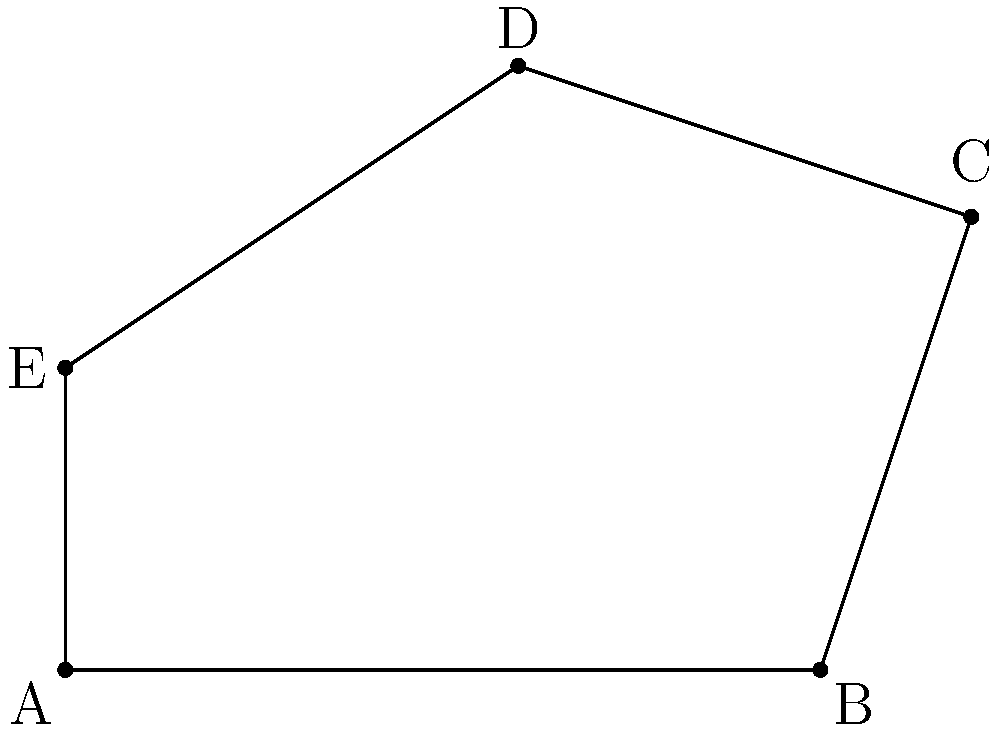As a health inspector, you're assessing a restaurant's food preparation area. The owner has designed an irregular-shaped countertop to maximize space efficiency. The coordinates (in feet) of the countertop's corners are A(0,0), B(5,0), C(6,3), D(3,4), and E(0,2). Calculate the total surface area of this food preparation surface to ensure it meets the minimum size requirements for safe food handling. To calculate the area of this irregular polygon, we can use the Shoelace formula (also known as the surveyor's formula). The steps are as follows:

1) First, let's arrange the coordinates in order:
   (0,0), (5,0), (6,3), (3,4), (0,2)

2) Apply the Shoelace formula:
   Area = $\frac{1}{2}|((x_1y_2 + x_2y_3 + x_3y_4 + x_4y_5 + x_5y_1) - (y_1x_2 + y_2x_3 + y_3x_4 + y_4x_5 + y_5x_1))|$

3) Substituting the values:
   Area = $\frac{1}{2}|((0 \cdot 0 + 5 \cdot 3 + 6 \cdot 4 + 3 \cdot 2 + 0 \cdot 0) - (0 \cdot 5 + 0 \cdot 6 + 3 \cdot 3 + 4 \cdot 0 + 2 \cdot 0))|$

4) Simplify:
   Area = $\frac{1}{2}|((0 + 15 + 24 + 6 + 0) - (0 + 0 + 9 + 0 + 0))|$
   Area = $\frac{1}{2}|(45 - 9)|$
   Area = $\frac{1}{2}(36)$
   Area = 18

Therefore, the total surface area of the food preparation surface is 18 square feet.
Answer: 18 sq ft 